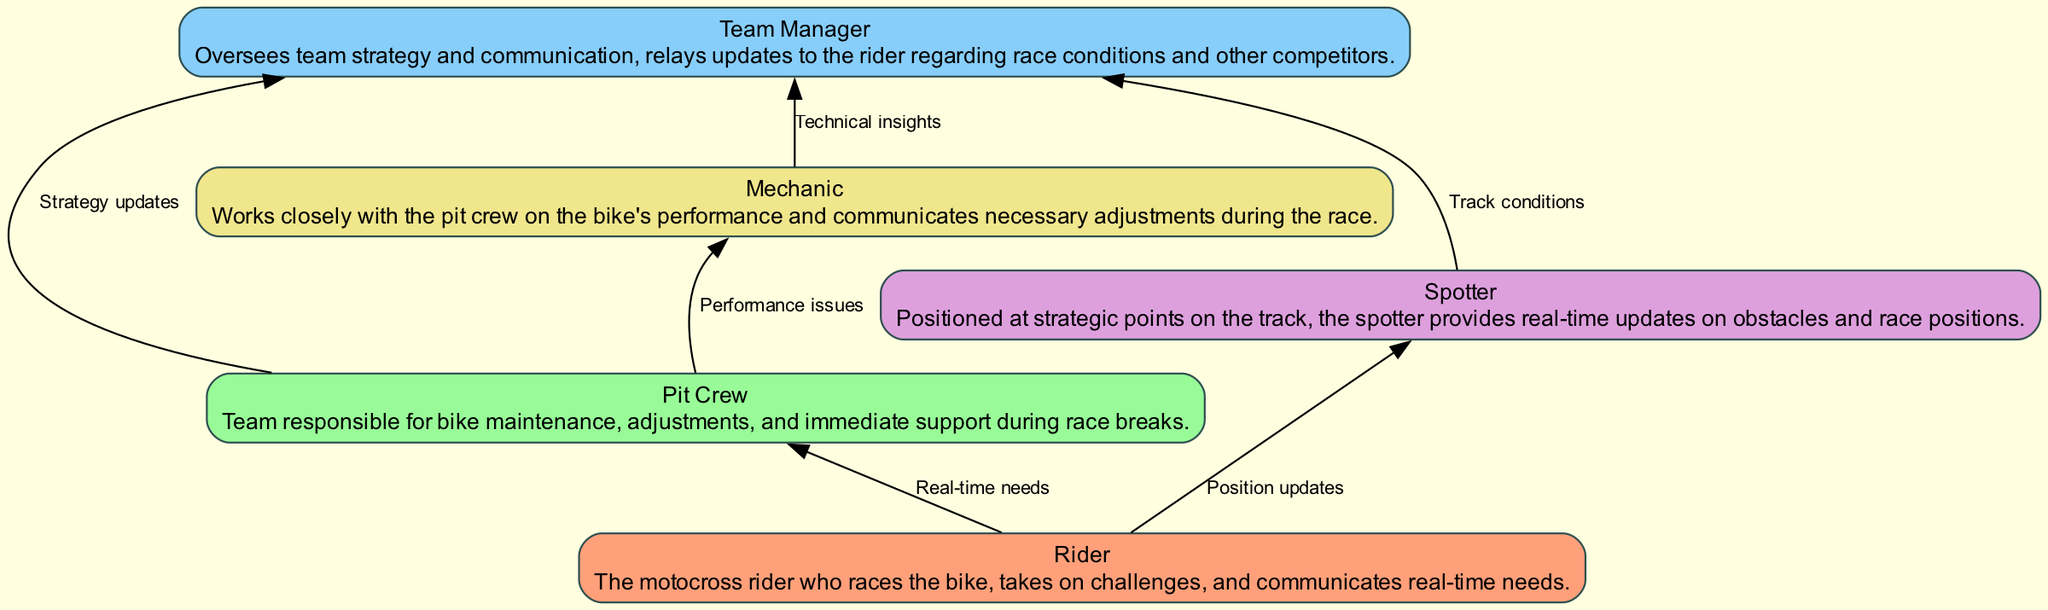What is the total number of nodes in the diagram? The diagram includes five distinct elements: Rider, Pit Crew, Team Manager, Spotter, and Mechanic. Counting each of these gives a total of five nodes.
Answer: 5 Which node communicates real-time needs? The "Rider" is specifically noted as the element that communicates real-time needs during the race.
Answer: Rider How many edges are connected to the Pit Crew? The Pit Crew has two outgoing edges: one to the Mechanic for performance issues and one to the Team Manager for strategy updates. This means the Pit Crew is connected by two edges.
Answer: 2 Who provides track conditions to the Team Manager? The "Spotter" provides real-time updates regarding track conditions to the Team Manager, as indicated by the directed edge in the diagram.
Answer: Spotter What does the Mechanic communicate to the Team Manager? The Mechanic communicates "Technical insights" to the Team Manager, as described by the connection between these two nodes in the flowchart.
Answer: Technical insights In what direction does the edge between the Rider and the Spotter flow? The edge flows from the Rider to the Spotter, indicating that the Rider is in communication with the Spotter.
Answer: Downward Which two entities communicate performance issues directly? The "Pit Crew" communicates performance issues directly to the "Mechanic," as shown by the directed edge in the diagram.
Answer: Pit Crew and Mechanic What type of updates does the Team Manager relay to the rider? The Team Manager relays updates concerning race conditions and other competitors to the Rider during the race.
Answer: Race conditions and competitors What is the primary role of the Spotter in the flowchart? The primary role of the Spotter is to provide real-time updates on obstacles and race positions by communicating with other team members.
Answer: Real-time updates 